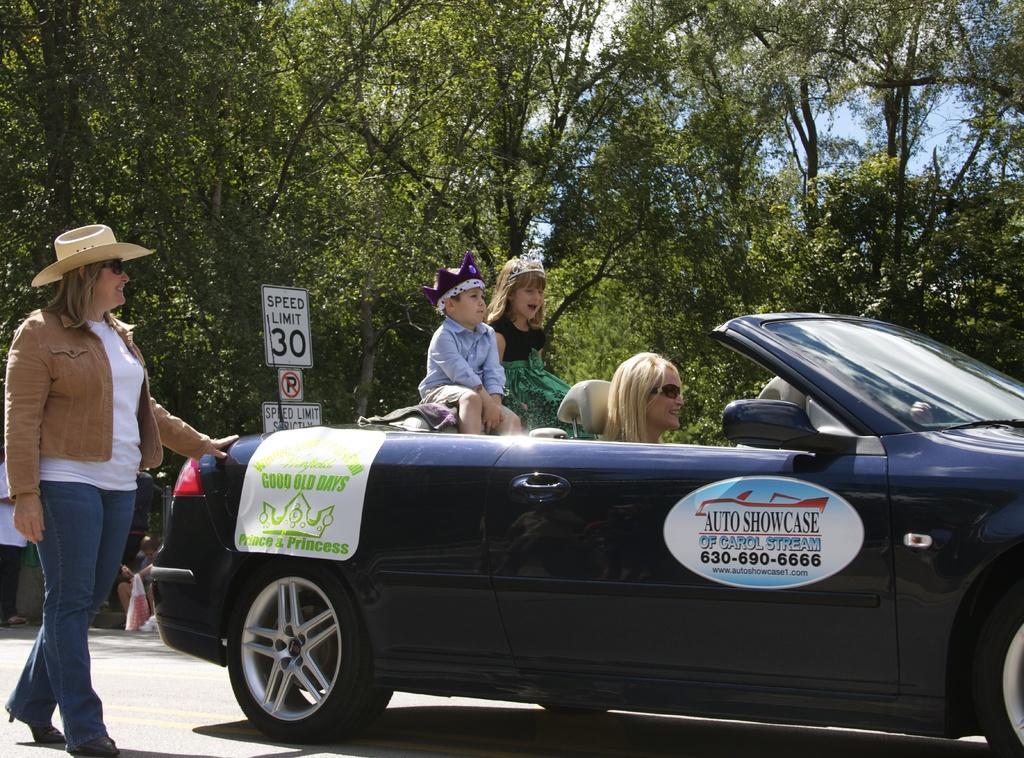Can you describe this image briefly? In this picture there is a lady who is driving the car and the two children sitting back side of her an advertisement is mentioned on the car that is auto show case and there are some trees around the road,the lady who is driving the car she is wearing sun glasses and the other lady who is standing on the road is touching the car from her left side 